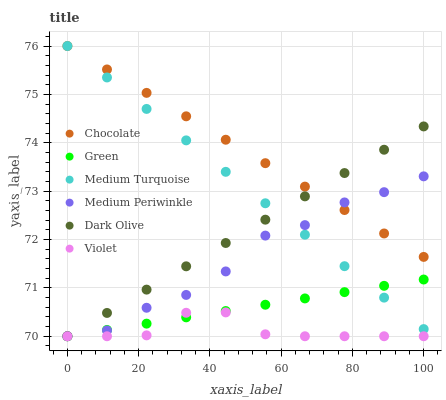Does Violet have the minimum area under the curve?
Answer yes or no. Yes. Does Chocolate have the maximum area under the curve?
Answer yes or no. Yes. Does Medium Periwinkle have the minimum area under the curve?
Answer yes or no. No. Does Medium Periwinkle have the maximum area under the curve?
Answer yes or no. No. Is Medium Turquoise the smoothest?
Answer yes or no. Yes. Is Medium Periwinkle the roughest?
Answer yes or no. Yes. Is Chocolate the smoothest?
Answer yes or no. No. Is Chocolate the roughest?
Answer yes or no. No. Does Dark Olive have the lowest value?
Answer yes or no. Yes. Does Chocolate have the lowest value?
Answer yes or no. No. Does Medium Turquoise have the highest value?
Answer yes or no. Yes. Does Medium Periwinkle have the highest value?
Answer yes or no. No. Is Violet less than Medium Turquoise?
Answer yes or no. Yes. Is Medium Turquoise greater than Violet?
Answer yes or no. Yes. Does Violet intersect Medium Periwinkle?
Answer yes or no. Yes. Is Violet less than Medium Periwinkle?
Answer yes or no. No. Is Violet greater than Medium Periwinkle?
Answer yes or no. No. Does Violet intersect Medium Turquoise?
Answer yes or no. No. 